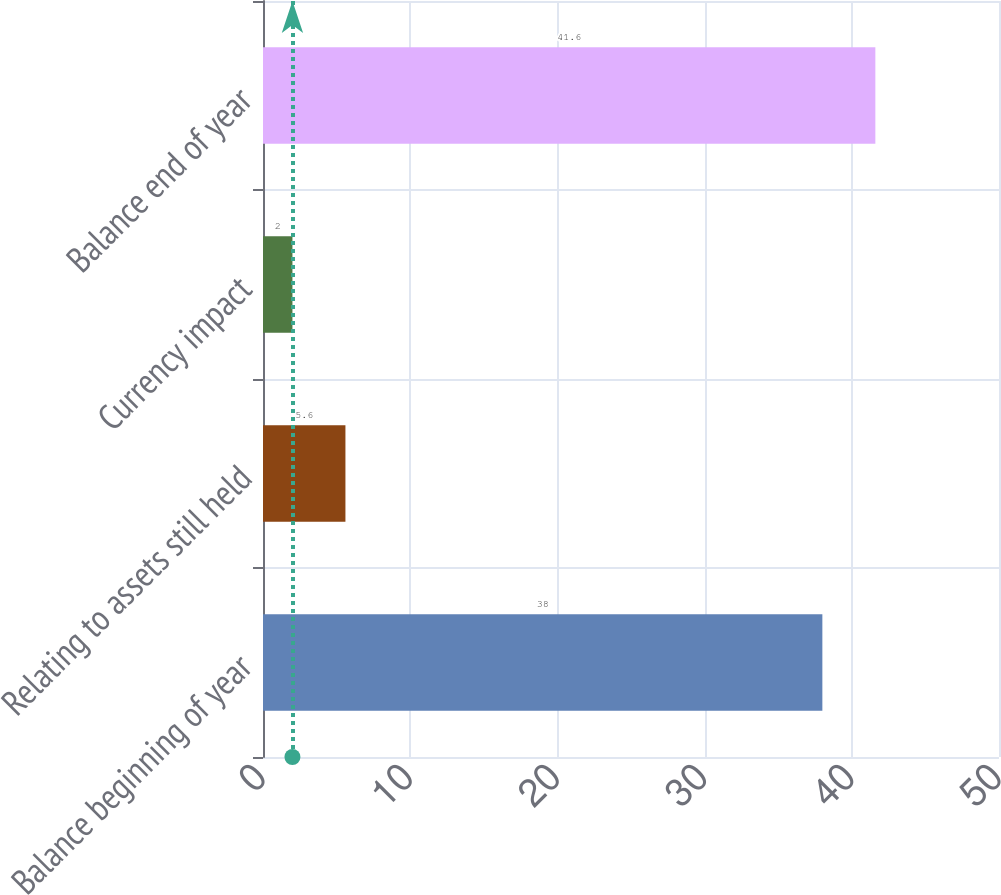Convert chart. <chart><loc_0><loc_0><loc_500><loc_500><bar_chart><fcel>Balance beginning of year<fcel>Relating to assets still held<fcel>Currency impact<fcel>Balance end of year<nl><fcel>38<fcel>5.6<fcel>2<fcel>41.6<nl></chart> 